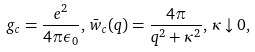<formula> <loc_0><loc_0><loc_500><loc_500>g _ { c } = \frac { e ^ { 2 } } { 4 \pi \epsilon _ { 0 } } , \, { \bar { w } } _ { c } ( q ) = \frac { 4 \pi } { q ^ { 2 } + \kappa ^ { 2 } } , \, \kappa \downarrow 0 ,</formula> 